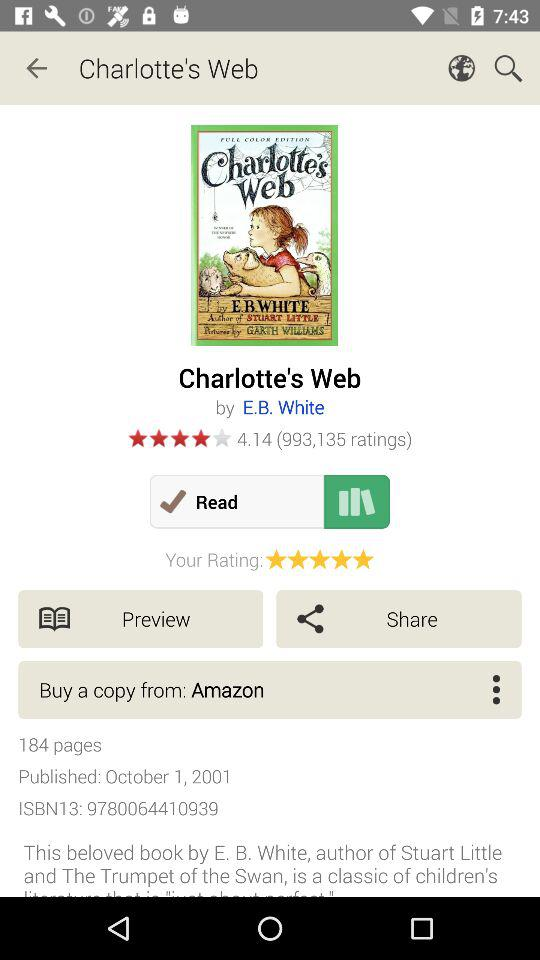From what application can we buy a copy of the book? You can buy a copy of the book from the application "Amazon". 